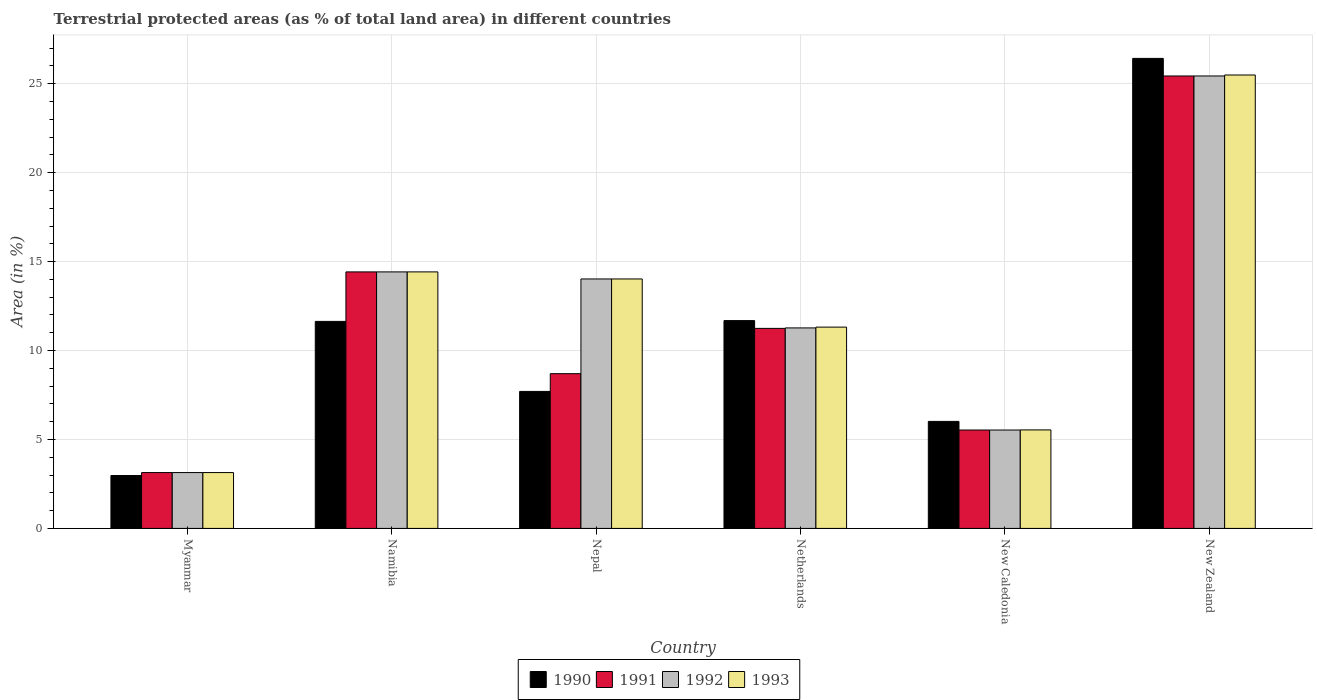How many different coloured bars are there?
Your answer should be compact. 4. What is the label of the 1st group of bars from the left?
Your answer should be very brief. Myanmar. In how many cases, is the number of bars for a given country not equal to the number of legend labels?
Offer a very short reply. 0. What is the percentage of terrestrial protected land in 1992 in New Zealand?
Make the answer very short. 25.44. Across all countries, what is the maximum percentage of terrestrial protected land in 1993?
Your answer should be very brief. 25.49. Across all countries, what is the minimum percentage of terrestrial protected land in 1993?
Your response must be concise. 3.14. In which country was the percentage of terrestrial protected land in 1993 maximum?
Give a very brief answer. New Zealand. In which country was the percentage of terrestrial protected land in 1991 minimum?
Ensure brevity in your answer.  Myanmar. What is the total percentage of terrestrial protected land in 1991 in the graph?
Your answer should be compact. 68.47. What is the difference between the percentage of terrestrial protected land in 1992 in Namibia and that in New Zealand?
Make the answer very short. -11.02. What is the difference between the percentage of terrestrial protected land in 1990 in New Zealand and the percentage of terrestrial protected land in 1991 in Namibia?
Provide a short and direct response. 12. What is the average percentage of terrestrial protected land in 1993 per country?
Ensure brevity in your answer.  12.32. What is the difference between the percentage of terrestrial protected land of/in 1990 and percentage of terrestrial protected land of/in 1993 in Myanmar?
Make the answer very short. -0.17. What is the ratio of the percentage of terrestrial protected land in 1991 in Namibia to that in Nepal?
Offer a very short reply. 1.66. What is the difference between the highest and the second highest percentage of terrestrial protected land in 1993?
Provide a succinct answer. 11.07. What is the difference between the highest and the lowest percentage of terrestrial protected land in 1992?
Your response must be concise. 22.3. In how many countries, is the percentage of terrestrial protected land in 1992 greater than the average percentage of terrestrial protected land in 1992 taken over all countries?
Ensure brevity in your answer.  3. Is it the case that in every country, the sum of the percentage of terrestrial protected land in 1993 and percentage of terrestrial protected land in 1990 is greater than the sum of percentage of terrestrial protected land in 1992 and percentage of terrestrial protected land in 1991?
Offer a very short reply. No. What does the 4th bar from the left in Myanmar represents?
Keep it short and to the point. 1993. What does the 4th bar from the right in Nepal represents?
Your response must be concise. 1990. How many bars are there?
Make the answer very short. 24. Does the graph contain any zero values?
Ensure brevity in your answer.  No. Does the graph contain grids?
Keep it short and to the point. Yes. How are the legend labels stacked?
Provide a succinct answer. Horizontal. What is the title of the graph?
Give a very brief answer. Terrestrial protected areas (as % of total land area) in different countries. What is the label or title of the Y-axis?
Provide a succinct answer. Area (in %). What is the Area (in %) in 1990 in Myanmar?
Provide a succinct answer. 2.97. What is the Area (in %) in 1991 in Myanmar?
Keep it short and to the point. 3.14. What is the Area (in %) in 1992 in Myanmar?
Offer a terse response. 3.14. What is the Area (in %) in 1993 in Myanmar?
Provide a succinct answer. 3.14. What is the Area (in %) in 1990 in Namibia?
Ensure brevity in your answer.  11.64. What is the Area (in %) of 1991 in Namibia?
Give a very brief answer. 14.42. What is the Area (in %) of 1992 in Namibia?
Make the answer very short. 14.42. What is the Area (in %) in 1993 in Namibia?
Give a very brief answer. 14.42. What is the Area (in %) in 1990 in Nepal?
Ensure brevity in your answer.  7.7. What is the Area (in %) of 1991 in Nepal?
Offer a very short reply. 8.7. What is the Area (in %) in 1992 in Nepal?
Keep it short and to the point. 14.02. What is the Area (in %) of 1993 in Nepal?
Provide a short and direct response. 14.02. What is the Area (in %) in 1990 in Netherlands?
Keep it short and to the point. 11.68. What is the Area (in %) of 1991 in Netherlands?
Offer a terse response. 11.25. What is the Area (in %) in 1992 in Netherlands?
Provide a short and direct response. 11.27. What is the Area (in %) in 1993 in Netherlands?
Your answer should be compact. 11.32. What is the Area (in %) of 1990 in New Caledonia?
Your answer should be very brief. 6.02. What is the Area (in %) of 1991 in New Caledonia?
Keep it short and to the point. 5.53. What is the Area (in %) of 1992 in New Caledonia?
Your answer should be compact. 5.53. What is the Area (in %) of 1993 in New Caledonia?
Your answer should be very brief. 5.54. What is the Area (in %) in 1990 in New Zealand?
Keep it short and to the point. 26.42. What is the Area (in %) of 1991 in New Zealand?
Your response must be concise. 25.44. What is the Area (in %) of 1992 in New Zealand?
Your response must be concise. 25.44. What is the Area (in %) in 1993 in New Zealand?
Offer a terse response. 25.49. Across all countries, what is the maximum Area (in %) of 1990?
Your answer should be very brief. 26.42. Across all countries, what is the maximum Area (in %) in 1991?
Offer a very short reply. 25.44. Across all countries, what is the maximum Area (in %) of 1992?
Keep it short and to the point. 25.44. Across all countries, what is the maximum Area (in %) in 1993?
Offer a terse response. 25.49. Across all countries, what is the minimum Area (in %) in 1990?
Make the answer very short. 2.97. Across all countries, what is the minimum Area (in %) in 1991?
Keep it short and to the point. 3.14. Across all countries, what is the minimum Area (in %) in 1992?
Provide a short and direct response. 3.14. Across all countries, what is the minimum Area (in %) of 1993?
Your answer should be very brief. 3.14. What is the total Area (in %) of 1990 in the graph?
Make the answer very short. 66.44. What is the total Area (in %) of 1991 in the graph?
Offer a very short reply. 68.47. What is the total Area (in %) in 1992 in the graph?
Provide a short and direct response. 73.82. What is the total Area (in %) in 1993 in the graph?
Provide a short and direct response. 73.93. What is the difference between the Area (in %) of 1990 in Myanmar and that in Namibia?
Offer a terse response. -8.67. What is the difference between the Area (in %) in 1991 in Myanmar and that in Namibia?
Your answer should be compact. -11.28. What is the difference between the Area (in %) of 1992 in Myanmar and that in Namibia?
Your answer should be compact. -11.28. What is the difference between the Area (in %) in 1993 in Myanmar and that in Namibia?
Provide a short and direct response. -11.28. What is the difference between the Area (in %) in 1990 in Myanmar and that in Nepal?
Provide a succinct answer. -4.73. What is the difference between the Area (in %) in 1991 in Myanmar and that in Nepal?
Give a very brief answer. -5.56. What is the difference between the Area (in %) in 1992 in Myanmar and that in Nepal?
Keep it short and to the point. -10.88. What is the difference between the Area (in %) in 1993 in Myanmar and that in Nepal?
Offer a terse response. -10.88. What is the difference between the Area (in %) of 1990 in Myanmar and that in Netherlands?
Give a very brief answer. -8.71. What is the difference between the Area (in %) in 1991 in Myanmar and that in Netherlands?
Provide a succinct answer. -8.11. What is the difference between the Area (in %) in 1992 in Myanmar and that in Netherlands?
Your answer should be very brief. -8.13. What is the difference between the Area (in %) in 1993 in Myanmar and that in Netherlands?
Keep it short and to the point. -8.18. What is the difference between the Area (in %) of 1990 in Myanmar and that in New Caledonia?
Offer a terse response. -3.04. What is the difference between the Area (in %) in 1991 in Myanmar and that in New Caledonia?
Your answer should be very brief. -2.39. What is the difference between the Area (in %) of 1992 in Myanmar and that in New Caledonia?
Keep it short and to the point. -2.39. What is the difference between the Area (in %) in 1993 in Myanmar and that in New Caledonia?
Your answer should be compact. -2.4. What is the difference between the Area (in %) of 1990 in Myanmar and that in New Zealand?
Your answer should be compact. -23.45. What is the difference between the Area (in %) of 1991 in Myanmar and that in New Zealand?
Keep it short and to the point. -22.3. What is the difference between the Area (in %) in 1992 in Myanmar and that in New Zealand?
Provide a succinct answer. -22.3. What is the difference between the Area (in %) of 1993 in Myanmar and that in New Zealand?
Make the answer very short. -22.35. What is the difference between the Area (in %) in 1990 in Namibia and that in Nepal?
Provide a succinct answer. 3.94. What is the difference between the Area (in %) of 1991 in Namibia and that in Nepal?
Offer a terse response. 5.72. What is the difference between the Area (in %) in 1992 in Namibia and that in Nepal?
Ensure brevity in your answer.  0.4. What is the difference between the Area (in %) of 1993 in Namibia and that in Nepal?
Provide a succinct answer. 0.4. What is the difference between the Area (in %) of 1990 in Namibia and that in Netherlands?
Your answer should be very brief. -0.04. What is the difference between the Area (in %) in 1991 in Namibia and that in Netherlands?
Provide a short and direct response. 3.18. What is the difference between the Area (in %) in 1992 in Namibia and that in Netherlands?
Provide a succinct answer. 3.15. What is the difference between the Area (in %) in 1993 in Namibia and that in Netherlands?
Offer a very short reply. 3.1. What is the difference between the Area (in %) in 1990 in Namibia and that in New Caledonia?
Provide a short and direct response. 5.62. What is the difference between the Area (in %) of 1991 in Namibia and that in New Caledonia?
Give a very brief answer. 8.89. What is the difference between the Area (in %) of 1992 in Namibia and that in New Caledonia?
Ensure brevity in your answer.  8.89. What is the difference between the Area (in %) in 1993 in Namibia and that in New Caledonia?
Your response must be concise. 8.88. What is the difference between the Area (in %) in 1990 in Namibia and that in New Zealand?
Ensure brevity in your answer.  -14.79. What is the difference between the Area (in %) of 1991 in Namibia and that in New Zealand?
Make the answer very short. -11.01. What is the difference between the Area (in %) in 1992 in Namibia and that in New Zealand?
Your answer should be very brief. -11.02. What is the difference between the Area (in %) in 1993 in Namibia and that in New Zealand?
Your response must be concise. -11.07. What is the difference between the Area (in %) in 1990 in Nepal and that in Netherlands?
Your answer should be very brief. -3.98. What is the difference between the Area (in %) in 1991 in Nepal and that in Netherlands?
Your answer should be compact. -2.55. What is the difference between the Area (in %) of 1992 in Nepal and that in Netherlands?
Make the answer very short. 2.75. What is the difference between the Area (in %) in 1993 in Nepal and that in Netherlands?
Provide a succinct answer. 2.71. What is the difference between the Area (in %) of 1990 in Nepal and that in New Caledonia?
Your answer should be very brief. 1.69. What is the difference between the Area (in %) of 1991 in Nepal and that in New Caledonia?
Offer a terse response. 3.17. What is the difference between the Area (in %) of 1992 in Nepal and that in New Caledonia?
Keep it short and to the point. 8.49. What is the difference between the Area (in %) of 1993 in Nepal and that in New Caledonia?
Your answer should be very brief. 8.49. What is the difference between the Area (in %) in 1990 in Nepal and that in New Zealand?
Your answer should be very brief. -18.72. What is the difference between the Area (in %) of 1991 in Nepal and that in New Zealand?
Keep it short and to the point. -16.74. What is the difference between the Area (in %) of 1992 in Nepal and that in New Zealand?
Ensure brevity in your answer.  -11.41. What is the difference between the Area (in %) in 1993 in Nepal and that in New Zealand?
Make the answer very short. -11.47. What is the difference between the Area (in %) in 1990 in Netherlands and that in New Caledonia?
Provide a short and direct response. 5.67. What is the difference between the Area (in %) of 1991 in Netherlands and that in New Caledonia?
Offer a very short reply. 5.71. What is the difference between the Area (in %) in 1992 in Netherlands and that in New Caledonia?
Give a very brief answer. 5.74. What is the difference between the Area (in %) in 1993 in Netherlands and that in New Caledonia?
Give a very brief answer. 5.78. What is the difference between the Area (in %) in 1990 in Netherlands and that in New Zealand?
Your answer should be compact. -14.74. What is the difference between the Area (in %) of 1991 in Netherlands and that in New Zealand?
Your answer should be very brief. -14.19. What is the difference between the Area (in %) of 1992 in Netherlands and that in New Zealand?
Offer a very short reply. -14.16. What is the difference between the Area (in %) in 1993 in Netherlands and that in New Zealand?
Your response must be concise. -14.17. What is the difference between the Area (in %) in 1990 in New Caledonia and that in New Zealand?
Offer a very short reply. -20.41. What is the difference between the Area (in %) in 1991 in New Caledonia and that in New Zealand?
Provide a short and direct response. -19.9. What is the difference between the Area (in %) of 1992 in New Caledonia and that in New Zealand?
Provide a short and direct response. -19.9. What is the difference between the Area (in %) of 1993 in New Caledonia and that in New Zealand?
Your response must be concise. -19.95. What is the difference between the Area (in %) in 1990 in Myanmar and the Area (in %) in 1991 in Namibia?
Your answer should be compact. -11.45. What is the difference between the Area (in %) in 1990 in Myanmar and the Area (in %) in 1992 in Namibia?
Give a very brief answer. -11.45. What is the difference between the Area (in %) in 1990 in Myanmar and the Area (in %) in 1993 in Namibia?
Provide a succinct answer. -11.45. What is the difference between the Area (in %) in 1991 in Myanmar and the Area (in %) in 1992 in Namibia?
Offer a terse response. -11.28. What is the difference between the Area (in %) in 1991 in Myanmar and the Area (in %) in 1993 in Namibia?
Offer a very short reply. -11.28. What is the difference between the Area (in %) of 1992 in Myanmar and the Area (in %) of 1993 in Namibia?
Your answer should be compact. -11.28. What is the difference between the Area (in %) in 1990 in Myanmar and the Area (in %) in 1991 in Nepal?
Provide a succinct answer. -5.73. What is the difference between the Area (in %) in 1990 in Myanmar and the Area (in %) in 1992 in Nepal?
Offer a very short reply. -11.05. What is the difference between the Area (in %) of 1990 in Myanmar and the Area (in %) of 1993 in Nepal?
Your answer should be compact. -11.05. What is the difference between the Area (in %) of 1991 in Myanmar and the Area (in %) of 1992 in Nepal?
Keep it short and to the point. -10.88. What is the difference between the Area (in %) of 1991 in Myanmar and the Area (in %) of 1993 in Nepal?
Keep it short and to the point. -10.88. What is the difference between the Area (in %) of 1992 in Myanmar and the Area (in %) of 1993 in Nepal?
Keep it short and to the point. -10.88. What is the difference between the Area (in %) of 1990 in Myanmar and the Area (in %) of 1991 in Netherlands?
Keep it short and to the point. -8.27. What is the difference between the Area (in %) of 1990 in Myanmar and the Area (in %) of 1992 in Netherlands?
Make the answer very short. -8.3. What is the difference between the Area (in %) in 1990 in Myanmar and the Area (in %) in 1993 in Netherlands?
Offer a very short reply. -8.34. What is the difference between the Area (in %) in 1991 in Myanmar and the Area (in %) in 1992 in Netherlands?
Provide a short and direct response. -8.13. What is the difference between the Area (in %) of 1991 in Myanmar and the Area (in %) of 1993 in Netherlands?
Your response must be concise. -8.18. What is the difference between the Area (in %) in 1992 in Myanmar and the Area (in %) in 1993 in Netherlands?
Keep it short and to the point. -8.18. What is the difference between the Area (in %) in 1990 in Myanmar and the Area (in %) in 1991 in New Caledonia?
Provide a succinct answer. -2.56. What is the difference between the Area (in %) of 1990 in Myanmar and the Area (in %) of 1992 in New Caledonia?
Your answer should be very brief. -2.56. What is the difference between the Area (in %) of 1990 in Myanmar and the Area (in %) of 1993 in New Caledonia?
Make the answer very short. -2.57. What is the difference between the Area (in %) in 1991 in Myanmar and the Area (in %) in 1992 in New Caledonia?
Make the answer very short. -2.39. What is the difference between the Area (in %) in 1991 in Myanmar and the Area (in %) in 1993 in New Caledonia?
Ensure brevity in your answer.  -2.4. What is the difference between the Area (in %) in 1992 in Myanmar and the Area (in %) in 1993 in New Caledonia?
Your answer should be very brief. -2.4. What is the difference between the Area (in %) of 1990 in Myanmar and the Area (in %) of 1991 in New Zealand?
Offer a very short reply. -22.46. What is the difference between the Area (in %) in 1990 in Myanmar and the Area (in %) in 1992 in New Zealand?
Offer a very short reply. -22.46. What is the difference between the Area (in %) of 1990 in Myanmar and the Area (in %) of 1993 in New Zealand?
Provide a short and direct response. -22.52. What is the difference between the Area (in %) in 1991 in Myanmar and the Area (in %) in 1992 in New Zealand?
Provide a short and direct response. -22.3. What is the difference between the Area (in %) of 1991 in Myanmar and the Area (in %) of 1993 in New Zealand?
Keep it short and to the point. -22.35. What is the difference between the Area (in %) in 1992 in Myanmar and the Area (in %) in 1993 in New Zealand?
Offer a terse response. -22.35. What is the difference between the Area (in %) of 1990 in Namibia and the Area (in %) of 1991 in Nepal?
Your answer should be compact. 2.94. What is the difference between the Area (in %) of 1990 in Namibia and the Area (in %) of 1992 in Nepal?
Provide a succinct answer. -2.39. What is the difference between the Area (in %) in 1990 in Namibia and the Area (in %) in 1993 in Nepal?
Provide a short and direct response. -2.39. What is the difference between the Area (in %) of 1991 in Namibia and the Area (in %) of 1992 in Nepal?
Provide a succinct answer. 0.4. What is the difference between the Area (in %) in 1991 in Namibia and the Area (in %) in 1993 in Nepal?
Ensure brevity in your answer.  0.4. What is the difference between the Area (in %) in 1992 in Namibia and the Area (in %) in 1993 in Nepal?
Give a very brief answer. 0.4. What is the difference between the Area (in %) in 1990 in Namibia and the Area (in %) in 1991 in Netherlands?
Offer a terse response. 0.39. What is the difference between the Area (in %) in 1990 in Namibia and the Area (in %) in 1992 in Netherlands?
Your response must be concise. 0.37. What is the difference between the Area (in %) of 1990 in Namibia and the Area (in %) of 1993 in Netherlands?
Your answer should be very brief. 0.32. What is the difference between the Area (in %) of 1991 in Namibia and the Area (in %) of 1992 in Netherlands?
Provide a short and direct response. 3.15. What is the difference between the Area (in %) in 1991 in Namibia and the Area (in %) in 1993 in Netherlands?
Your response must be concise. 3.1. What is the difference between the Area (in %) in 1992 in Namibia and the Area (in %) in 1993 in Netherlands?
Your answer should be compact. 3.1. What is the difference between the Area (in %) of 1990 in Namibia and the Area (in %) of 1991 in New Caledonia?
Your response must be concise. 6.11. What is the difference between the Area (in %) in 1990 in Namibia and the Area (in %) in 1992 in New Caledonia?
Your response must be concise. 6.11. What is the difference between the Area (in %) of 1990 in Namibia and the Area (in %) of 1993 in New Caledonia?
Provide a short and direct response. 6.1. What is the difference between the Area (in %) of 1991 in Namibia and the Area (in %) of 1992 in New Caledonia?
Provide a short and direct response. 8.89. What is the difference between the Area (in %) in 1991 in Namibia and the Area (in %) in 1993 in New Caledonia?
Give a very brief answer. 8.88. What is the difference between the Area (in %) of 1992 in Namibia and the Area (in %) of 1993 in New Caledonia?
Your answer should be very brief. 8.88. What is the difference between the Area (in %) in 1990 in Namibia and the Area (in %) in 1991 in New Zealand?
Give a very brief answer. -13.8. What is the difference between the Area (in %) of 1990 in Namibia and the Area (in %) of 1992 in New Zealand?
Give a very brief answer. -13.8. What is the difference between the Area (in %) of 1990 in Namibia and the Area (in %) of 1993 in New Zealand?
Your answer should be very brief. -13.85. What is the difference between the Area (in %) of 1991 in Namibia and the Area (in %) of 1992 in New Zealand?
Offer a very short reply. -11.02. What is the difference between the Area (in %) in 1991 in Namibia and the Area (in %) in 1993 in New Zealand?
Provide a succinct answer. -11.07. What is the difference between the Area (in %) in 1992 in Namibia and the Area (in %) in 1993 in New Zealand?
Offer a terse response. -11.07. What is the difference between the Area (in %) in 1990 in Nepal and the Area (in %) in 1991 in Netherlands?
Offer a terse response. -3.54. What is the difference between the Area (in %) in 1990 in Nepal and the Area (in %) in 1992 in Netherlands?
Ensure brevity in your answer.  -3.57. What is the difference between the Area (in %) in 1990 in Nepal and the Area (in %) in 1993 in Netherlands?
Your answer should be very brief. -3.61. What is the difference between the Area (in %) in 1991 in Nepal and the Area (in %) in 1992 in Netherlands?
Your answer should be compact. -2.57. What is the difference between the Area (in %) in 1991 in Nepal and the Area (in %) in 1993 in Netherlands?
Keep it short and to the point. -2.62. What is the difference between the Area (in %) in 1992 in Nepal and the Area (in %) in 1993 in Netherlands?
Make the answer very short. 2.71. What is the difference between the Area (in %) in 1990 in Nepal and the Area (in %) in 1991 in New Caledonia?
Provide a short and direct response. 2.17. What is the difference between the Area (in %) in 1990 in Nepal and the Area (in %) in 1992 in New Caledonia?
Make the answer very short. 2.17. What is the difference between the Area (in %) in 1990 in Nepal and the Area (in %) in 1993 in New Caledonia?
Make the answer very short. 2.16. What is the difference between the Area (in %) of 1991 in Nepal and the Area (in %) of 1992 in New Caledonia?
Offer a terse response. 3.17. What is the difference between the Area (in %) in 1991 in Nepal and the Area (in %) in 1993 in New Caledonia?
Your answer should be compact. 3.16. What is the difference between the Area (in %) of 1992 in Nepal and the Area (in %) of 1993 in New Caledonia?
Your response must be concise. 8.49. What is the difference between the Area (in %) in 1990 in Nepal and the Area (in %) in 1991 in New Zealand?
Provide a short and direct response. -17.73. What is the difference between the Area (in %) in 1990 in Nepal and the Area (in %) in 1992 in New Zealand?
Ensure brevity in your answer.  -17.73. What is the difference between the Area (in %) of 1990 in Nepal and the Area (in %) of 1993 in New Zealand?
Provide a succinct answer. -17.79. What is the difference between the Area (in %) in 1991 in Nepal and the Area (in %) in 1992 in New Zealand?
Provide a succinct answer. -16.74. What is the difference between the Area (in %) in 1991 in Nepal and the Area (in %) in 1993 in New Zealand?
Offer a terse response. -16.79. What is the difference between the Area (in %) of 1992 in Nepal and the Area (in %) of 1993 in New Zealand?
Ensure brevity in your answer.  -11.47. What is the difference between the Area (in %) in 1990 in Netherlands and the Area (in %) in 1991 in New Caledonia?
Your answer should be very brief. 6.15. What is the difference between the Area (in %) of 1990 in Netherlands and the Area (in %) of 1992 in New Caledonia?
Your answer should be very brief. 6.15. What is the difference between the Area (in %) in 1990 in Netherlands and the Area (in %) in 1993 in New Caledonia?
Offer a very short reply. 6.15. What is the difference between the Area (in %) in 1991 in Netherlands and the Area (in %) in 1992 in New Caledonia?
Ensure brevity in your answer.  5.71. What is the difference between the Area (in %) in 1991 in Netherlands and the Area (in %) in 1993 in New Caledonia?
Provide a short and direct response. 5.71. What is the difference between the Area (in %) of 1992 in Netherlands and the Area (in %) of 1993 in New Caledonia?
Your response must be concise. 5.73. What is the difference between the Area (in %) in 1990 in Netherlands and the Area (in %) in 1991 in New Zealand?
Ensure brevity in your answer.  -13.75. What is the difference between the Area (in %) of 1990 in Netherlands and the Area (in %) of 1992 in New Zealand?
Your answer should be very brief. -13.75. What is the difference between the Area (in %) of 1990 in Netherlands and the Area (in %) of 1993 in New Zealand?
Your answer should be very brief. -13.81. What is the difference between the Area (in %) of 1991 in Netherlands and the Area (in %) of 1992 in New Zealand?
Make the answer very short. -14.19. What is the difference between the Area (in %) in 1991 in Netherlands and the Area (in %) in 1993 in New Zealand?
Make the answer very short. -14.25. What is the difference between the Area (in %) in 1992 in Netherlands and the Area (in %) in 1993 in New Zealand?
Your answer should be very brief. -14.22. What is the difference between the Area (in %) of 1990 in New Caledonia and the Area (in %) of 1991 in New Zealand?
Offer a very short reply. -19.42. What is the difference between the Area (in %) of 1990 in New Caledonia and the Area (in %) of 1992 in New Zealand?
Provide a succinct answer. -19.42. What is the difference between the Area (in %) of 1990 in New Caledonia and the Area (in %) of 1993 in New Zealand?
Provide a short and direct response. -19.47. What is the difference between the Area (in %) in 1991 in New Caledonia and the Area (in %) in 1992 in New Zealand?
Your response must be concise. -19.9. What is the difference between the Area (in %) of 1991 in New Caledonia and the Area (in %) of 1993 in New Zealand?
Provide a short and direct response. -19.96. What is the difference between the Area (in %) of 1992 in New Caledonia and the Area (in %) of 1993 in New Zealand?
Give a very brief answer. -19.96. What is the average Area (in %) in 1990 per country?
Provide a succinct answer. 11.07. What is the average Area (in %) in 1991 per country?
Keep it short and to the point. 11.41. What is the average Area (in %) in 1992 per country?
Offer a very short reply. 12.3. What is the average Area (in %) of 1993 per country?
Keep it short and to the point. 12.32. What is the difference between the Area (in %) in 1990 and Area (in %) in 1992 in Myanmar?
Provide a short and direct response. -0.17. What is the difference between the Area (in %) in 1990 and Area (in %) in 1993 in Myanmar?
Ensure brevity in your answer.  -0.17. What is the difference between the Area (in %) in 1992 and Area (in %) in 1993 in Myanmar?
Your response must be concise. 0. What is the difference between the Area (in %) in 1990 and Area (in %) in 1991 in Namibia?
Your answer should be very brief. -2.78. What is the difference between the Area (in %) in 1990 and Area (in %) in 1992 in Namibia?
Your response must be concise. -2.78. What is the difference between the Area (in %) of 1990 and Area (in %) of 1993 in Namibia?
Provide a succinct answer. -2.78. What is the difference between the Area (in %) in 1990 and Area (in %) in 1991 in Nepal?
Provide a short and direct response. -1. What is the difference between the Area (in %) of 1990 and Area (in %) of 1992 in Nepal?
Keep it short and to the point. -6.32. What is the difference between the Area (in %) of 1990 and Area (in %) of 1993 in Nepal?
Give a very brief answer. -6.32. What is the difference between the Area (in %) in 1991 and Area (in %) in 1992 in Nepal?
Keep it short and to the point. -5.32. What is the difference between the Area (in %) in 1991 and Area (in %) in 1993 in Nepal?
Provide a short and direct response. -5.32. What is the difference between the Area (in %) of 1992 and Area (in %) of 1993 in Nepal?
Your response must be concise. 0. What is the difference between the Area (in %) in 1990 and Area (in %) in 1991 in Netherlands?
Your response must be concise. 0.44. What is the difference between the Area (in %) in 1990 and Area (in %) in 1992 in Netherlands?
Your answer should be very brief. 0.41. What is the difference between the Area (in %) of 1990 and Area (in %) of 1993 in Netherlands?
Offer a very short reply. 0.37. What is the difference between the Area (in %) in 1991 and Area (in %) in 1992 in Netherlands?
Your answer should be very brief. -0.03. What is the difference between the Area (in %) in 1991 and Area (in %) in 1993 in Netherlands?
Ensure brevity in your answer.  -0.07. What is the difference between the Area (in %) of 1992 and Area (in %) of 1993 in Netherlands?
Your response must be concise. -0.05. What is the difference between the Area (in %) of 1990 and Area (in %) of 1991 in New Caledonia?
Provide a short and direct response. 0.48. What is the difference between the Area (in %) of 1990 and Area (in %) of 1992 in New Caledonia?
Provide a short and direct response. 0.48. What is the difference between the Area (in %) in 1990 and Area (in %) in 1993 in New Caledonia?
Keep it short and to the point. 0.48. What is the difference between the Area (in %) in 1991 and Area (in %) in 1993 in New Caledonia?
Your answer should be compact. -0.01. What is the difference between the Area (in %) in 1992 and Area (in %) in 1993 in New Caledonia?
Your response must be concise. -0.01. What is the difference between the Area (in %) of 1990 and Area (in %) of 1991 in New Zealand?
Keep it short and to the point. 0.99. What is the difference between the Area (in %) of 1990 and Area (in %) of 1992 in New Zealand?
Your answer should be compact. 0.99. What is the difference between the Area (in %) of 1990 and Area (in %) of 1993 in New Zealand?
Offer a terse response. 0.93. What is the difference between the Area (in %) of 1991 and Area (in %) of 1992 in New Zealand?
Give a very brief answer. -0. What is the difference between the Area (in %) in 1991 and Area (in %) in 1993 in New Zealand?
Offer a terse response. -0.06. What is the difference between the Area (in %) of 1992 and Area (in %) of 1993 in New Zealand?
Give a very brief answer. -0.06. What is the ratio of the Area (in %) in 1990 in Myanmar to that in Namibia?
Ensure brevity in your answer.  0.26. What is the ratio of the Area (in %) of 1991 in Myanmar to that in Namibia?
Make the answer very short. 0.22. What is the ratio of the Area (in %) of 1992 in Myanmar to that in Namibia?
Your answer should be very brief. 0.22. What is the ratio of the Area (in %) in 1993 in Myanmar to that in Namibia?
Provide a succinct answer. 0.22. What is the ratio of the Area (in %) in 1990 in Myanmar to that in Nepal?
Offer a terse response. 0.39. What is the ratio of the Area (in %) of 1991 in Myanmar to that in Nepal?
Keep it short and to the point. 0.36. What is the ratio of the Area (in %) of 1992 in Myanmar to that in Nepal?
Your answer should be very brief. 0.22. What is the ratio of the Area (in %) in 1993 in Myanmar to that in Nepal?
Give a very brief answer. 0.22. What is the ratio of the Area (in %) of 1990 in Myanmar to that in Netherlands?
Your answer should be compact. 0.25. What is the ratio of the Area (in %) of 1991 in Myanmar to that in Netherlands?
Your response must be concise. 0.28. What is the ratio of the Area (in %) in 1992 in Myanmar to that in Netherlands?
Your response must be concise. 0.28. What is the ratio of the Area (in %) of 1993 in Myanmar to that in Netherlands?
Your response must be concise. 0.28. What is the ratio of the Area (in %) of 1990 in Myanmar to that in New Caledonia?
Make the answer very short. 0.49. What is the ratio of the Area (in %) of 1991 in Myanmar to that in New Caledonia?
Provide a succinct answer. 0.57. What is the ratio of the Area (in %) in 1992 in Myanmar to that in New Caledonia?
Offer a very short reply. 0.57. What is the ratio of the Area (in %) in 1993 in Myanmar to that in New Caledonia?
Keep it short and to the point. 0.57. What is the ratio of the Area (in %) in 1990 in Myanmar to that in New Zealand?
Your answer should be very brief. 0.11. What is the ratio of the Area (in %) of 1991 in Myanmar to that in New Zealand?
Offer a very short reply. 0.12. What is the ratio of the Area (in %) in 1992 in Myanmar to that in New Zealand?
Keep it short and to the point. 0.12. What is the ratio of the Area (in %) in 1993 in Myanmar to that in New Zealand?
Keep it short and to the point. 0.12. What is the ratio of the Area (in %) of 1990 in Namibia to that in Nepal?
Offer a very short reply. 1.51. What is the ratio of the Area (in %) in 1991 in Namibia to that in Nepal?
Make the answer very short. 1.66. What is the ratio of the Area (in %) of 1992 in Namibia to that in Nepal?
Provide a succinct answer. 1.03. What is the ratio of the Area (in %) in 1993 in Namibia to that in Nepal?
Make the answer very short. 1.03. What is the ratio of the Area (in %) of 1991 in Namibia to that in Netherlands?
Ensure brevity in your answer.  1.28. What is the ratio of the Area (in %) of 1992 in Namibia to that in Netherlands?
Provide a short and direct response. 1.28. What is the ratio of the Area (in %) of 1993 in Namibia to that in Netherlands?
Your answer should be very brief. 1.27. What is the ratio of the Area (in %) in 1990 in Namibia to that in New Caledonia?
Offer a terse response. 1.93. What is the ratio of the Area (in %) in 1991 in Namibia to that in New Caledonia?
Your response must be concise. 2.61. What is the ratio of the Area (in %) of 1992 in Namibia to that in New Caledonia?
Offer a terse response. 2.61. What is the ratio of the Area (in %) of 1993 in Namibia to that in New Caledonia?
Offer a terse response. 2.6. What is the ratio of the Area (in %) in 1990 in Namibia to that in New Zealand?
Provide a short and direct response. 0.44. What is the ratio of the Area (in %) of 1991 in Namibia to that in New Zealand?
Ensure brevity in your answer.  0.57. What is the ratio of the Area (in %) of 1992 in Namibia to that in New Zealand?
Ensure brevity in your answer.  0.57. What is the ratio of the Area (in %) in 1993 in Namibia to that in New Zealand?
Make the answer very short. 0.57. What is the ratio of the Area (in %) of 1990 in Nepal to that in Netherlands?
Provide a short and direct response. 0.66. What is the ratio of the Area (in %) of 1991 in Nepal to that in Netherlands?
Provide a succinct answer. 0.77. What is the ratio of the Area (in %) of 1992 in Nepal to that in Netherlands?
Your response must be concise. 1.24. What is the ratio of the Area (in %) of 1993 in Nepal to that in Netherlands?
Provide a short and direct response. 1.24. What is the ratio of the Area (in %) of 1990 in Nepal to that in New Caledonia?
Your answer should be compact. 1.28. What is the ratio of the Area (in %) of 1991 in Nepal to that in New Caledonia?
Offer a very short reply. 1.57. What is the ratio of the Area (in %) in 1992 in Nepal to that in New Caledonia?
Ensure brevity in your answer.  2.54. What is the ratio of the Area (in %) of 1993 in Nepal to that in New Caledonia?
Your answer should be very brief. 2.53. What is the ratio of the Area (in %) of 1990 in Nepal to that in New Zealand?
Provide a short and direct response. 0.29. What is the ratio of the Area (in %) in 1991 in Nepal to that in New Zealand?
Your response must be concise. 0.34. What is the ratio of the Area (in %) of 1992 in Nepal to that in New Zealand?
Ensure brevity in your answer.  0.55. What is the ratio of the Area (in %) in 1993 in Nepal to that in New Zealand?
Give a very brief answer. 0.55. What is the ratio of the Area (in %) of 1990 in Netherlands to that in New Caledonia?
Offer a very short reply. 1.94. What is the ratio of the Area (in %) in 1991 in Netherlands to that in New Caledonia?
Offer a very short reply. 2.03. What is the ratio of the Area (in %) in 1992 in Netherlands to that in New Caledonia?
Ensure brevity in your answer.  2.04. What is the ratio of the Area (in %) of 1993 in Netherlands to that in New Caledonia?
Offer a terse response. 2.04. What is the ratio of the Area (in %) of 1990 in Netherlands to that in New Zealand?
Provide a succinct answer. 0.44. What is the ratio of the Area (in %) in 1991 in Netherlands to that in New Zealand?
Give a very brief answer. 0.44. What is the ratio of the Area (in %) of 1992 in Netherlands to that in New Zealand?
Offer a terse response. 0.44. What is the ratio of the Area (in %) in 1993 in Netherlands to that in New Zealand?
Your answer should be very brief. 0.44. What is the ratio of the Area (in %) of 1990 in New Caledonia to that in New Zealand?
Your answer should be very brief. 0.23. What is the ratio of the Area (in %) in 1991 in New Caledonia to that in New Zealand?
Offer a very short reply. 0.22. What is the ratio of the Area (in %) of 1992 in New Caledonia to that in New Zealand?
Provide a short and direct response. 0.22. What is the ratio of the Area (in %) of 1993 in New Caledonia to that in New Zealand?
Give a very brief answer. 0.22. What is the difference between the highest and the second highest Area (in %) of 1990?
Give a very brief answer. 14.74. What is the difference between the highest and the second highest Area (in %) of 1991?
Ensure brevity in your answer.  11.01. What is the difference between the highest and the second highest Area (in %) in 1992?
Your answer should be compact. 11.02. What is the difference between the highest and the second highest Area (in %) of 1993?
Make the answer very short. 11.07. What is the difference between the highest and the lowest Area (in %) in 1990?
Offer a very short reply. 23.45. What is the difference between the highest and the lowest Area (in %) in 1991?
Provide a short and direct response. 22.3. What is the difference between the highest and the lowest Area (in %) in 1992?
Make the answer very short. 22.3. What is the difference between the highest and the lowest Area (in %) of 1993?
Offer a very short reply. 22.35. 